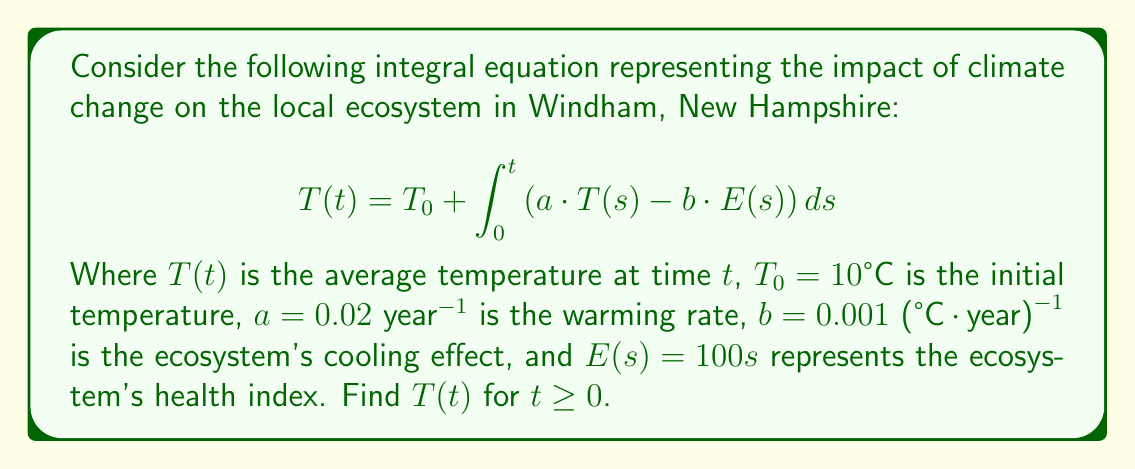Solve this math problem. To solve this integral equation, we'll follow these steps:

1) First, we differentiate both sides of the equation with respect to $t$:
   $$\frac{dT}{dt} = a \cdot T(t) - b \cdot E(t)$$

2) Substitute $E(t) = 100t$:
   $$\frac{dT}{dt} = a \cdot T(t) - 100bt$$

3) This is a first-order linear differential equation. The general solution is:
   $$T(t) = c \cdot e^{at} - \frac{100b}{a}t - \frac{100b}{a^2}$$
   where $c$ is a constant to be determined.

4) To find $c$, we use the initial condition $T(0) = T_0 = 10°C$:
   $$10 = c - \frac{100b}{a^2}$$
   $$c = 10 + \frac{100b}{a^2}$$

5) Substituting the values $a = 0.02$ and $b = 0.001$:
   $$c = 10 + \frac{100 \cdot 0.001}{0.02^2} = 10 + 25 = 35$$

6) Therefore, the final solution is:
   $$T(t) = 35 \cdot e^{0.02t} - 5t - 25$$

This equation represents how the average temperature in Windham changes over time due to climate change, considering the local ecosystem's cooling effect.
Answer: $T(t) = 35 \cdot e^{0.02t} - 5t - 25$ 